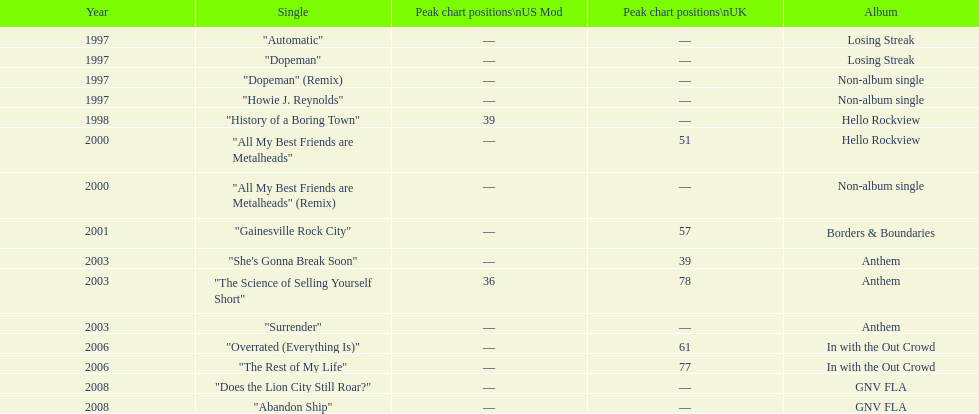Which single was released before "dopeman"? "Automatic". 